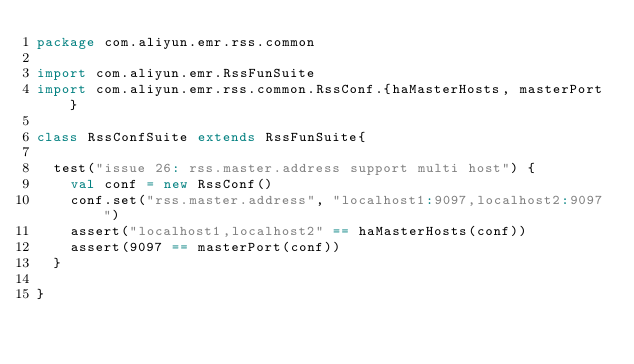Convert code to text. <code><loc_0><loc_0><loc_500><loc_500><_Scala_>package com.aliyun.emr.rss.common

import com.aliyun.emr.RssFunSuite
import com.aliyun.emr.rss.common.RssConf.{haMasterHosts, masterPort}

class RssConfSuite extends RssFunSuite{

  test("issue 26: rss.master.address support multi host") {
    val conf = new RssConf()
    conf.set("rss.master.address", "localhost1:9097,localhost2:9097")
    assert("localhost1,localhost2" == haMasterHosts(conf))
    assert(9097 == masterPort(conf))
  }

}
</code> 